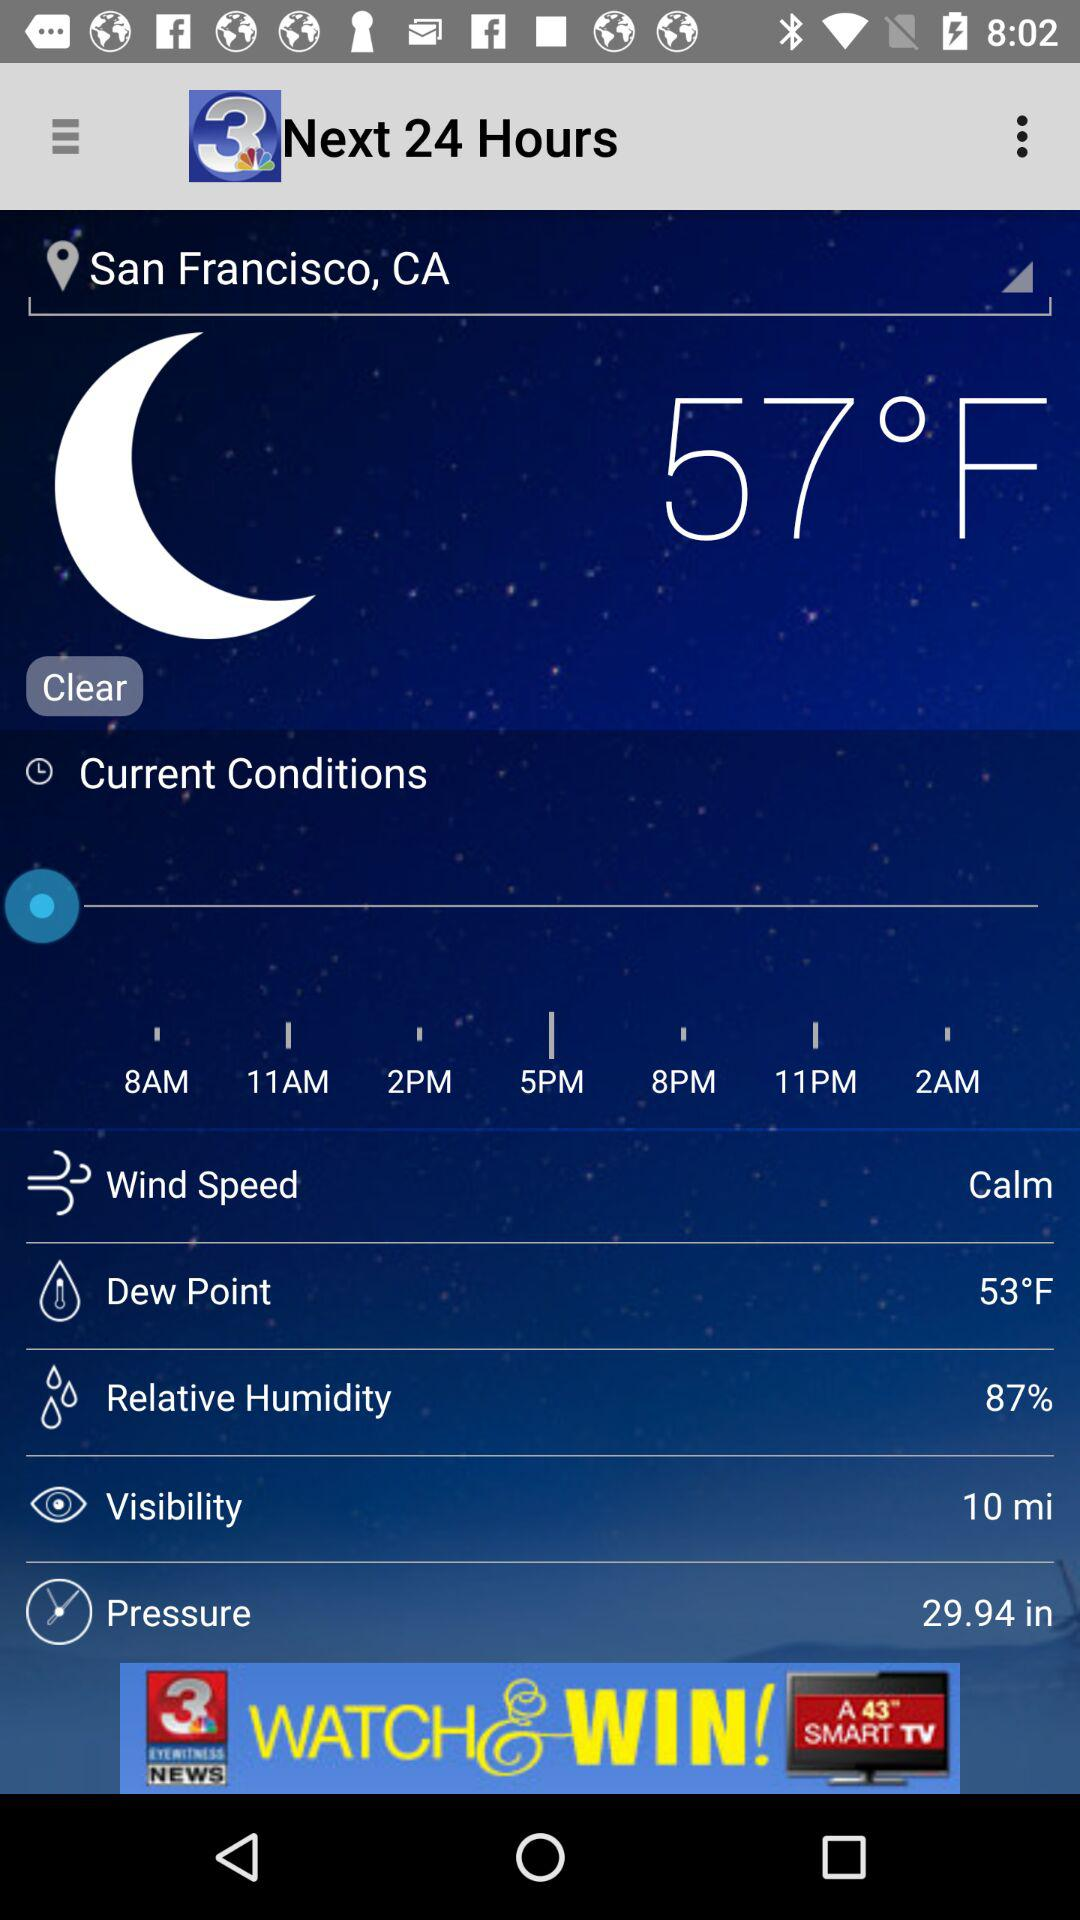What is the temperature? The temperature is 57 °F. 